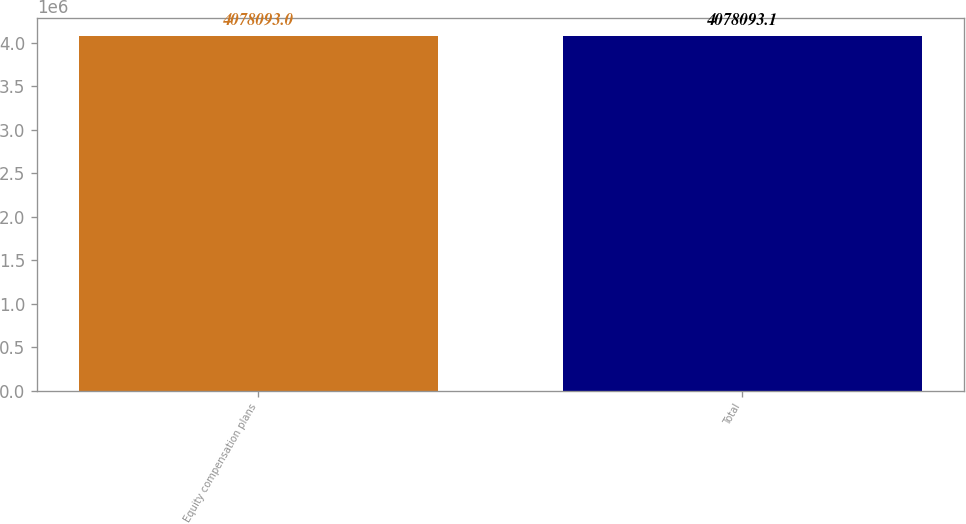Convert chart. <chart><loc_0><loc_0><loc_500><loc_500><bar_chart><fcel>Equity compensation plans<fcel>Total<nl><fcel>4.07809e+06<fcel>4.07809e+06<nl></chart> 